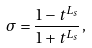<formula> <loc_0><loc_0><loc_500><loc_500>\sigma = \frac { 1 - t ^ { L _ { s } } } { 1 + t ^ { L _ { s } } } \, ,</formula> 